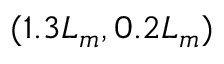<formula> <loc_0><loc_0><loc_500><loc_500>( 1 . 3 L _ { m } , 0 . 2 L _ { m } )</formula> 